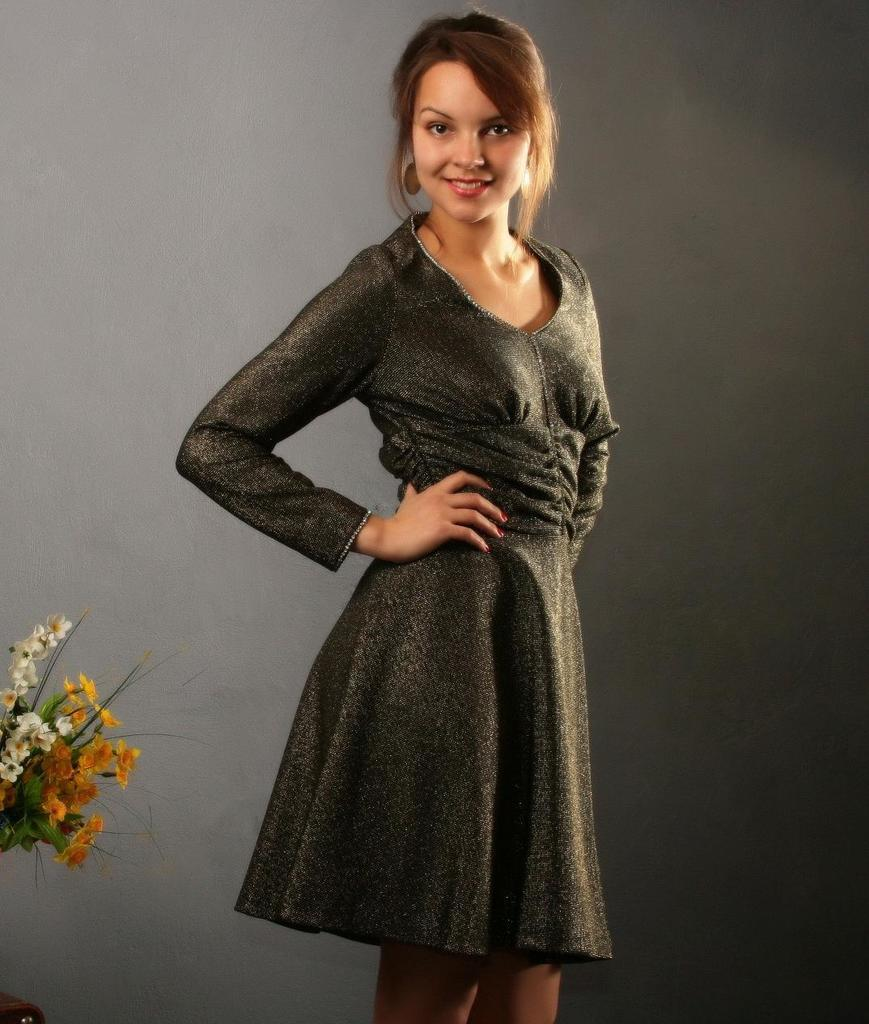Who is present in the image? There is a woman in the image. What is the woman doing in the image? The woman is smiling in the image. What can be seen on the left side of the image? There are flowers on the left side of the image. What is visible in the background of the image? There is a wall in the background of the image. What type of mountain is visible in the image? There is no mountain present in the image. What authority figure can be seen in the image? There is no authority figure present in the image; it features a woman smiling and flowers on the left side. 